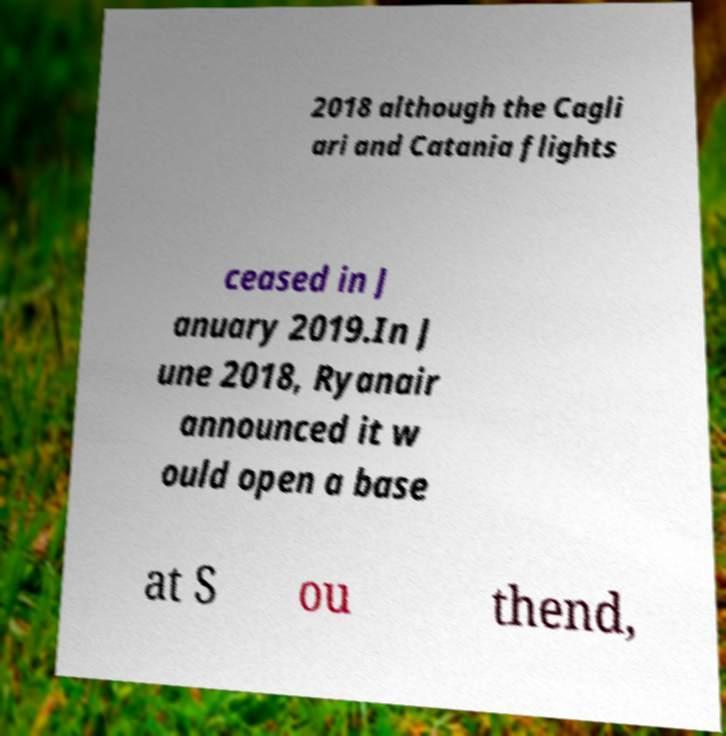What messages or text are displayed in this image? I need them in a readable, typed format. 2018 although the Cagli ari and Catania flights ceased in J anuary 2019.In J une 2018, Ryanair announced it w ould open a base at S ou thend, 